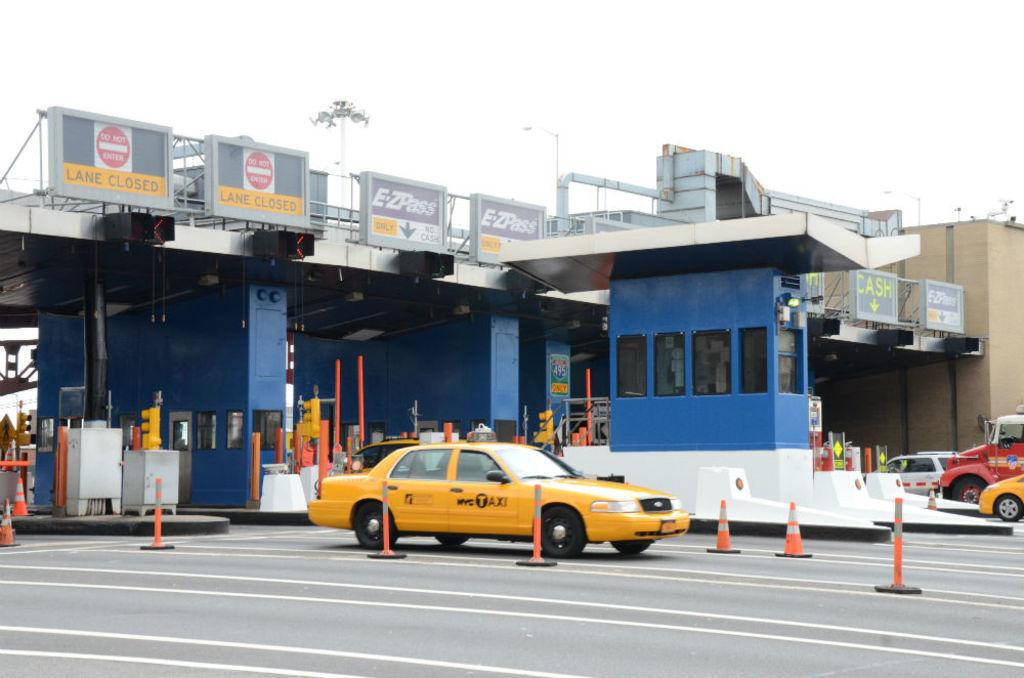<image>
Share a concise interpretation of the image provided. A yellow vehicle with the word Taxi written on one side. 